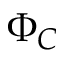<formula> <loc_0><loc_0><loc_500><loc_500>\Phi _ { C }</formula> 